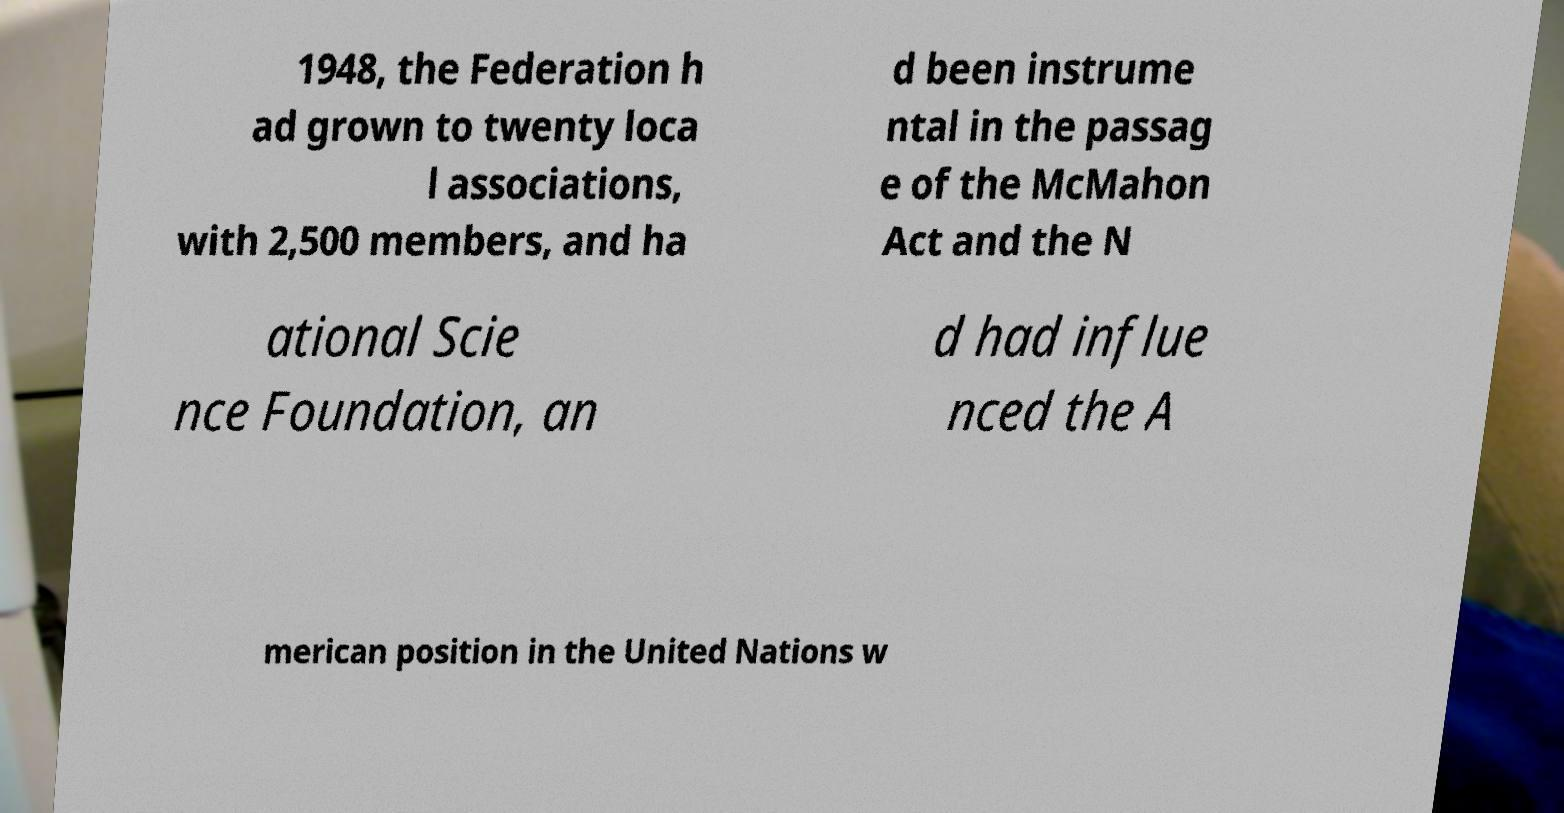There's text embedded in this image that I need extracted. Can you transcribe it verbatim? 1948, the Federation h ad grown to twenty loca l associations, with 2,500 members, and ha d been instrume ntal in the passag e of the McMahon Act and the N ational Scie nce Foundation, an d had influe nced the A merican position in the United Nations w 